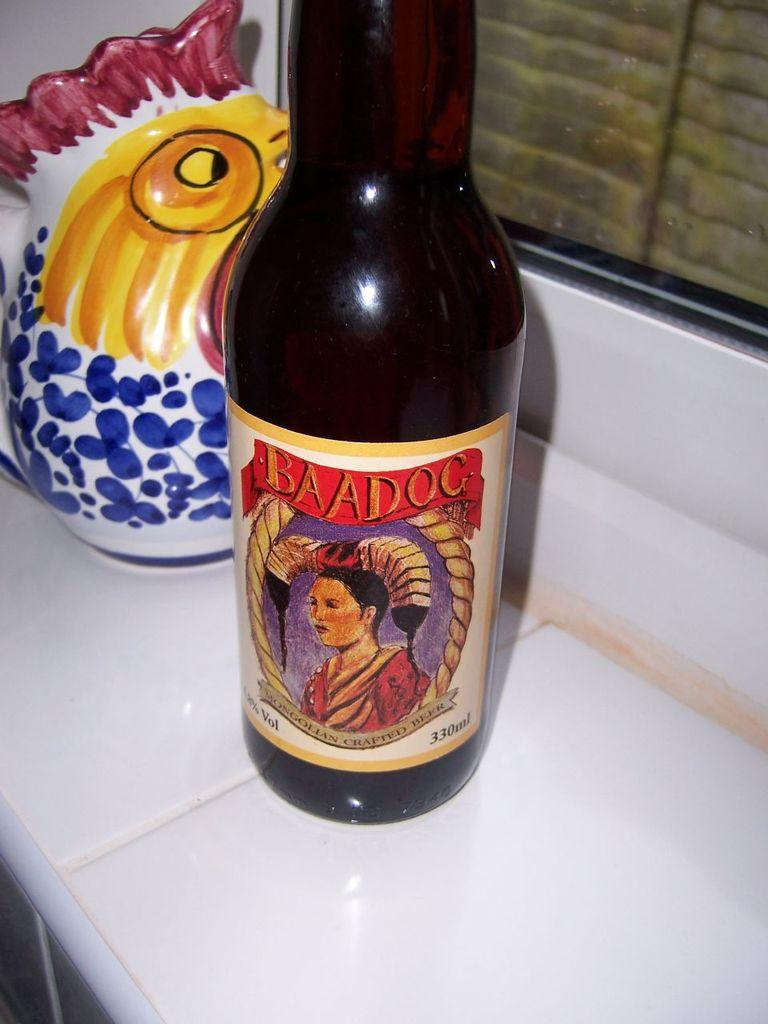<image>
Describe the image concisely. The Baadog beer has the picture of an Asian woman on it. 